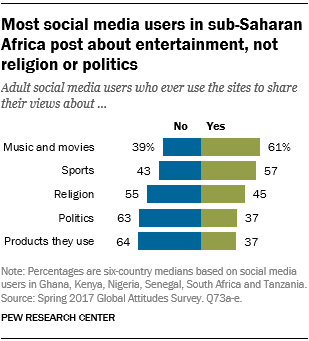Mention a couple of crucial points in this snapshot. According to a recent survey, 61% of the public share their views about music and movies. According to the data, approximately 2.322916667... people out of the total public do not share their views about religion, while 2.322916667... people out of the total public do share their views about religion. 